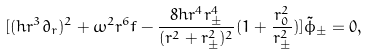Convert formula to latex. <formula><loc_0><loc_0><loc_500><loc_500>[ ( h r ^ { 3 } \partial _ { r } ) ^ { 2 } + \omega ^ { 2 } r ^ { 6 } f - \frac { 8 h r ^ { 4 } r _ { \pm } ^ { 4 } } { ( r ^ { 2 } + r _ { \pm } ^ { 2 } ) ^ { 2 } } ( 1 + \frac { r _ { 0 } ^ { 2 } } { r _ { \pm } ^ { 2 } } ) ] \tilde { \phi } _ { \pm } = 0 ,</formula> 